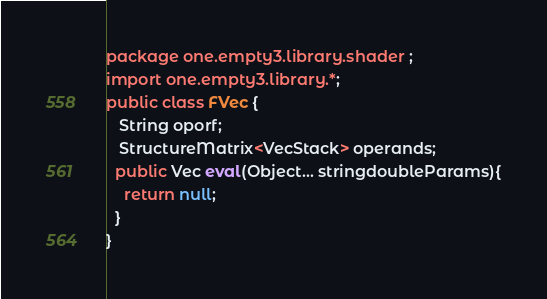Convert code to text. <code><loc_0><loc_0><loc_500><loc_500><_Java_>package one.empty3.library.shader ;
import one.empty3.library.*;
public class FVec {
   String oporf;
   StructureMatrix<VecStack> operands;
  public Vec eval(Object... stringdoubleParams){
    return null;
  } 
} 
</code> 